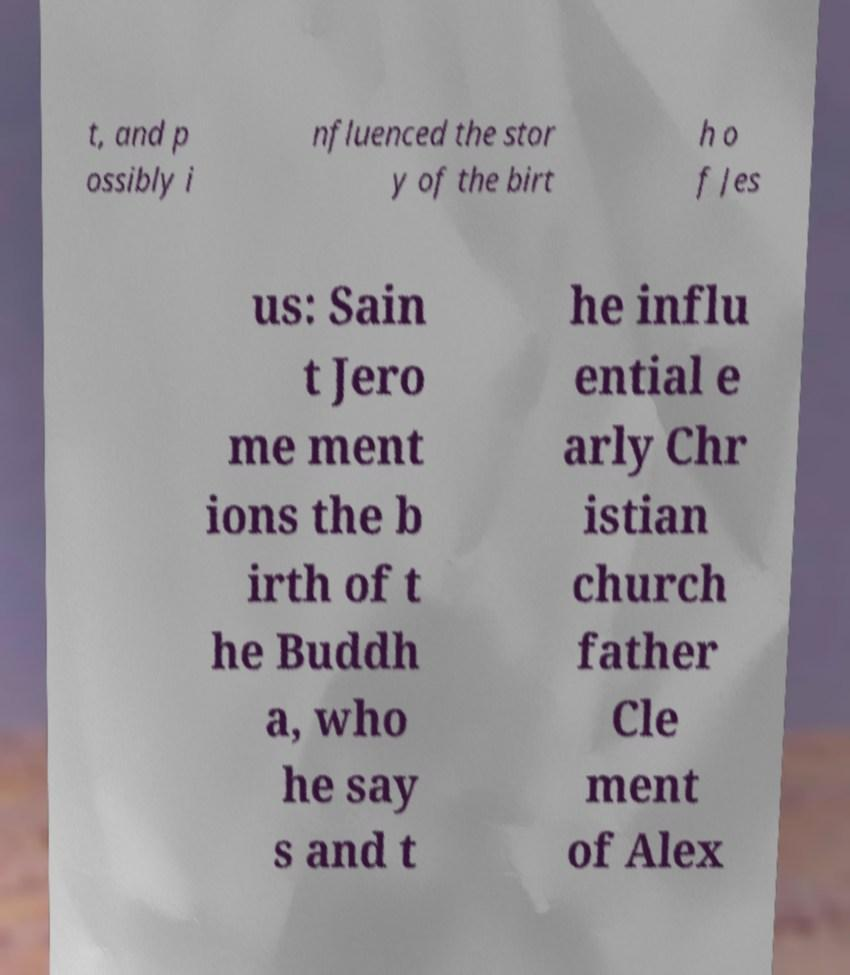I need the written content from this picture converted into text. Can you do that? t, and p ossibly i nfluenced the stor y of the birt h o f Jes us: Sain t Jero me ment ions the b irth of t he Buddh a, who he say s and t he influ ential e arly Chr istian church father Cle ment of Alex 